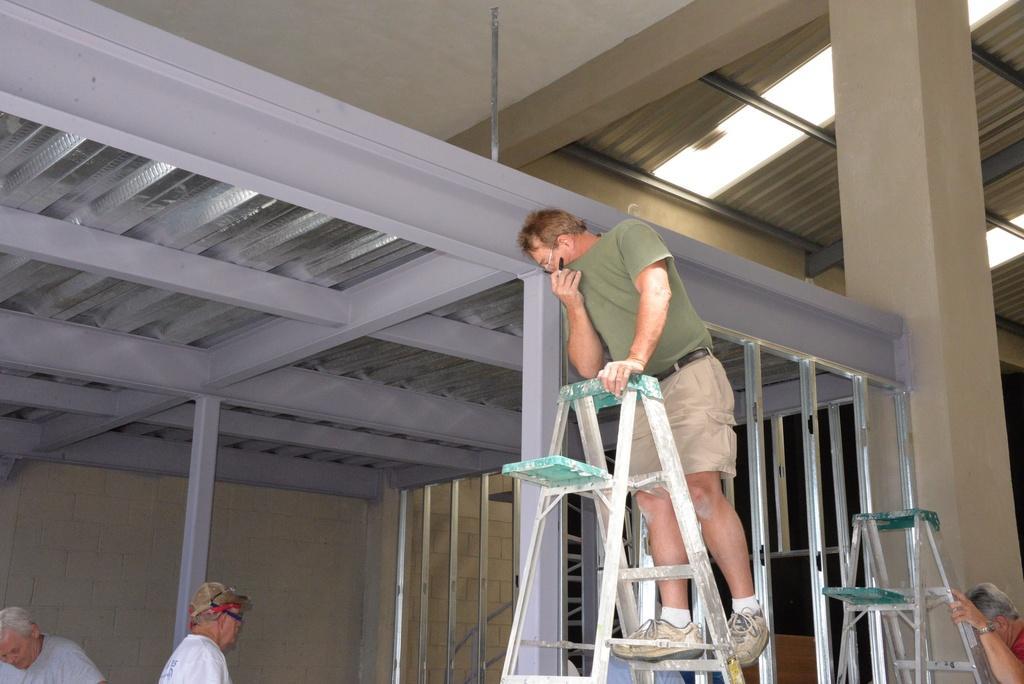Could you give a brief overview of what you see in this image? In the picture I can see a man standing on the ladder and looks like he is holding a sketch pen in his right hand. He is wearing a green color T-shirt and a short. There is another ladder and a man on the bottom right side of the picture. I can see two persons on the bottom left side. I can see the metal sheet roofing on the top right side. In the picture I can see the stainless steel fence. 